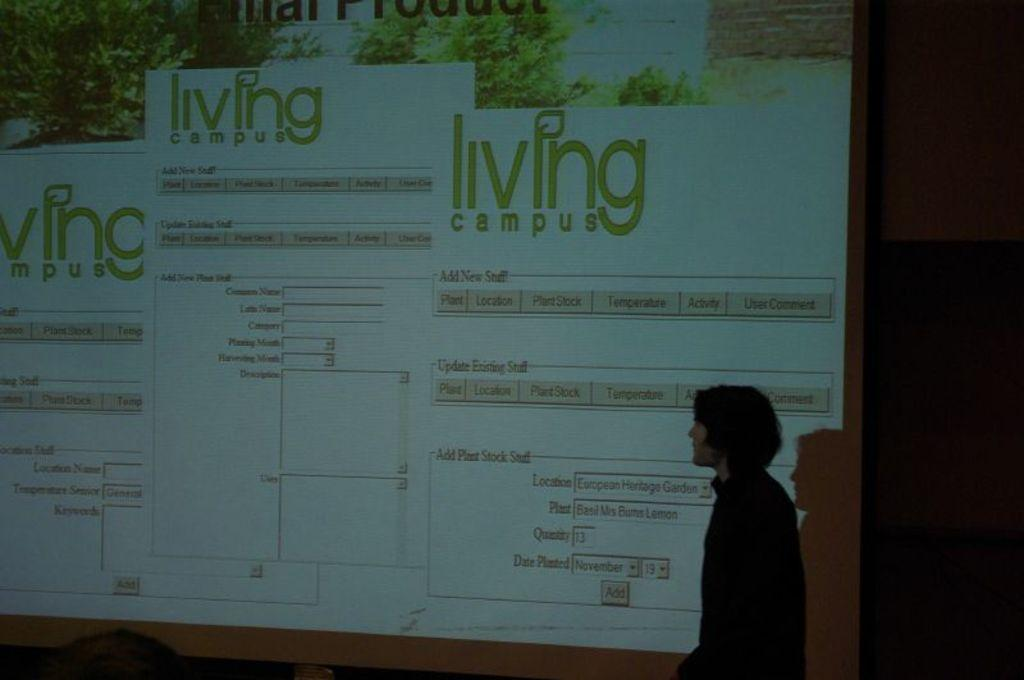Provide a one-sentence caption for the provided image. A screen displaying the name living campus a few times. 